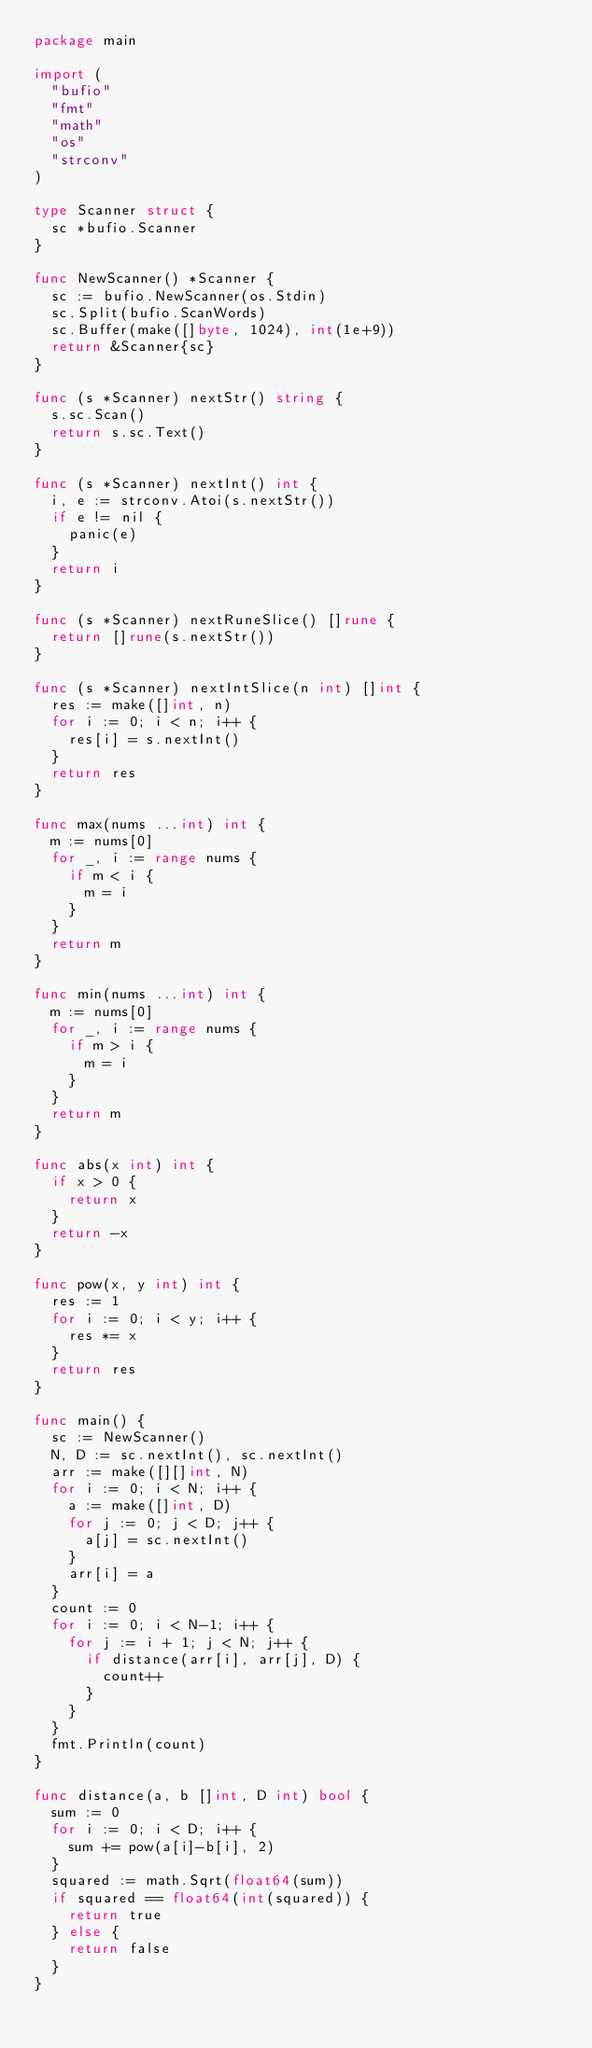<code> <loc_0><loc_0><loc_500><loc_500><_Go_>package main

import (
	"bufio"
	"fmt"
	"math"
	"os"
	"strconv"
)

type Scanner struct {
	sc *bufio.Scanner
}

func NewScanner() *Scanner {
	sc := bufio.NewScanner(os.Stdin)
	sc.Split(bufio.ScanWords)
	sc.Buffer(make([]byte, 1024), int(1e+9))
	return &Scanner{sc}
}

func (s *Scanner) nextStr() string {
	s.sc.Scan()
	return s.sc.Text()
}

func (s *Scanner) nextInt() int {
	i, e := strconv.Atoi(s.nextStr())
	if e != nil {
		panic(e)
	}
	return i
}

func (s *Scanner) nextRuneSlice() []rune {
	return []rune(s.nextStr())
}

func (s *Scanner) nextIntSlice(n int) []int {
	res := make([]int, n)
	for i := 0; i < n; i++ {
		res[i] = s.nextInt()
	}
	return res
}

func max(nums ...int) int {
	m := nums[0]
	for _, i := range nums {
		if m < i {
			m = i
		}
	}
	return m
}

func min(nums ...int) int {
	m := nums[0]
	for _, i := range nums {
		if m > i {
			m = i
		}
	}
	return m
}

func abs(x int) int {
	if x > 0 {
		return x
	}
	return -x
}

func pow(x, y int) int {
	res := 1
	for i := 0; i < y; i++ {
		res *= x
	}
	return res
}

func main() {
	sc := NewScanner()
	N, D := sc.nextInt(), sc.nextInt()
	arr := make([][]int, N)
	for i := 0; i < N; i++ {
		a := make([]int, D)
		for j := 0; j < D; j++ {
			a[j] = sc.nextInt()
		}
		arr[i] = a
	}
	count := 0
	for i := 0; i < N-1; i++ {
		for j := i + 1; j < N; j++ {
			if distance(arr[i], arr[j], D) {
				count++
			}
		}
	}
	fmt.Println(count)
}

func distance(a, b []int, D int) bool {
	sum := 0
	for i := 0; i < D; i++ {
		sum += pow(a[i]-b[i], 2)
	}
	squared := math.Sqrt(float64(sum))
	if squared == float64(int(squared)) {
		return true
	} else {
		return false
	}
}
</code> 